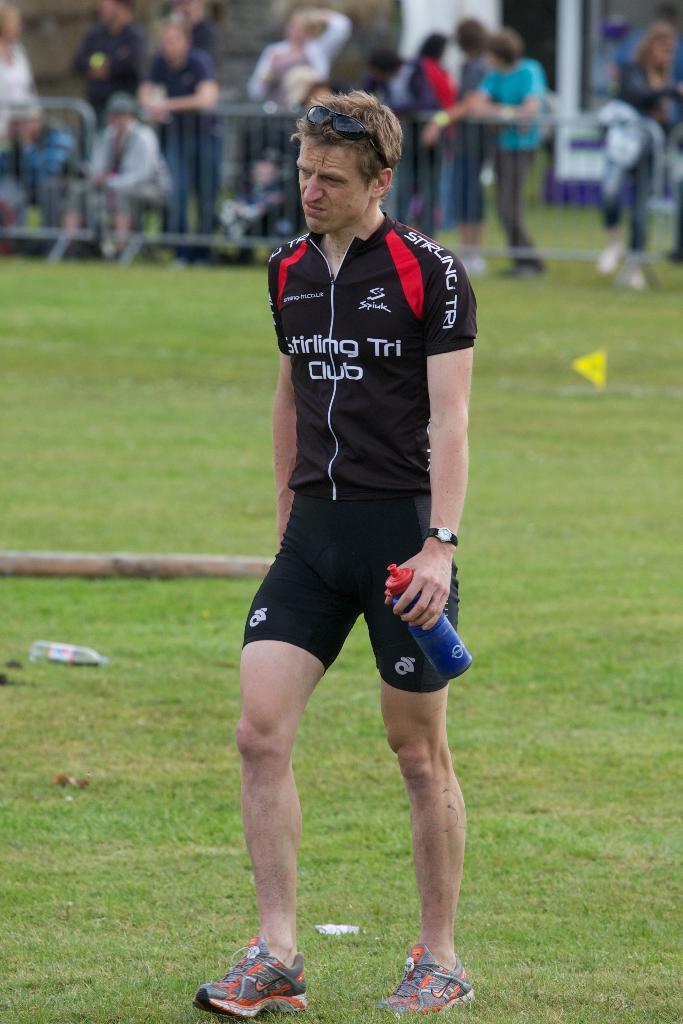What kind of club is he in?
Ensure brevity in your answer.  Stirling tri club. 